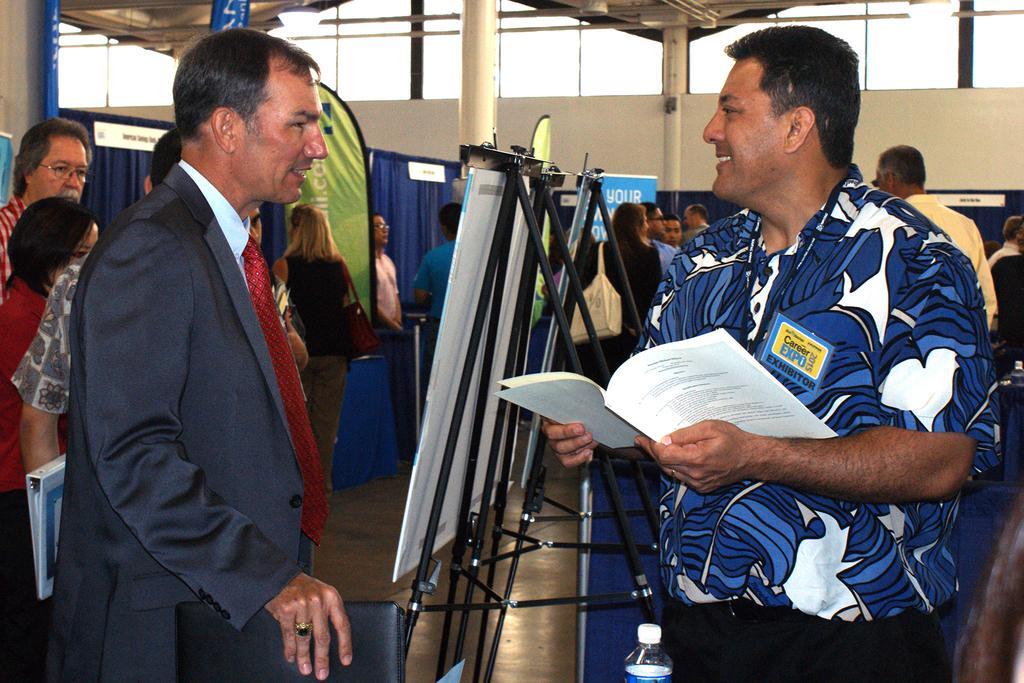Describe this image in one or two sentences. In this image I can see group of people standing. In front the person is wearing blue and white color shirt and holding the file and I can see few boards to the stands. In the background I can see few curtains in blue color and the wall is in cream color. 